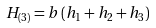Convert formula to latex. <formula><loc_0><loc_0><loc_500><loc_500>H _ { ( 3 ) } = b \left ( h _ { 1 } + h _ { 2 } + h _ { 3 } \right )</formula> 